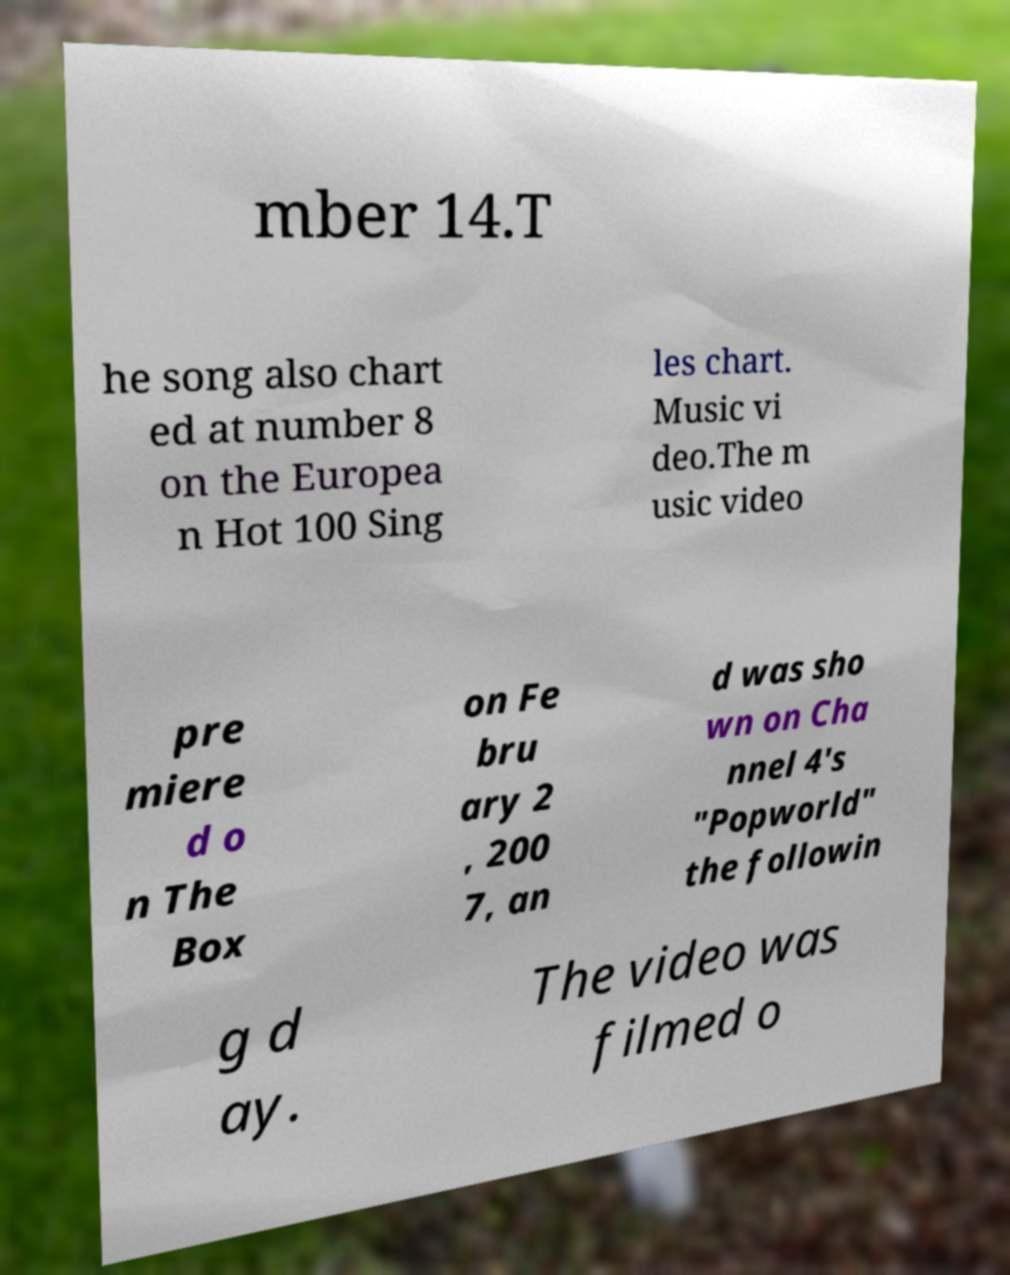Please identify and transcribe the text found in this image. mber 14.T he song also chart ed at number 8 on the Europea n Hot 100 Sing les chart. Music vi deo.The m usic video pre miere d o n The Box on Fe bru ary 2 , 200 7, an d was sho wn on Cha nnel 4's "Popworld" the followin g d ay. The video was filmed o 